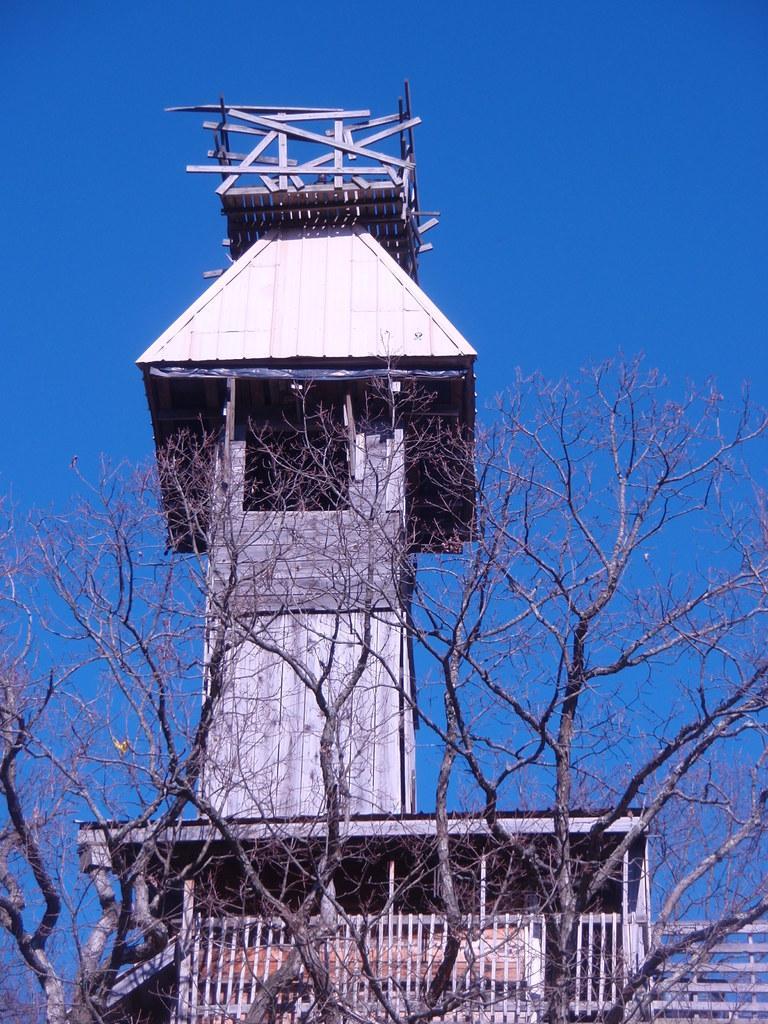Please provide a concise description of this image. This image is clicked outside. There are trees in the middle. There is sky at the top. There is a house like thing in the middle. It is built with wood. 